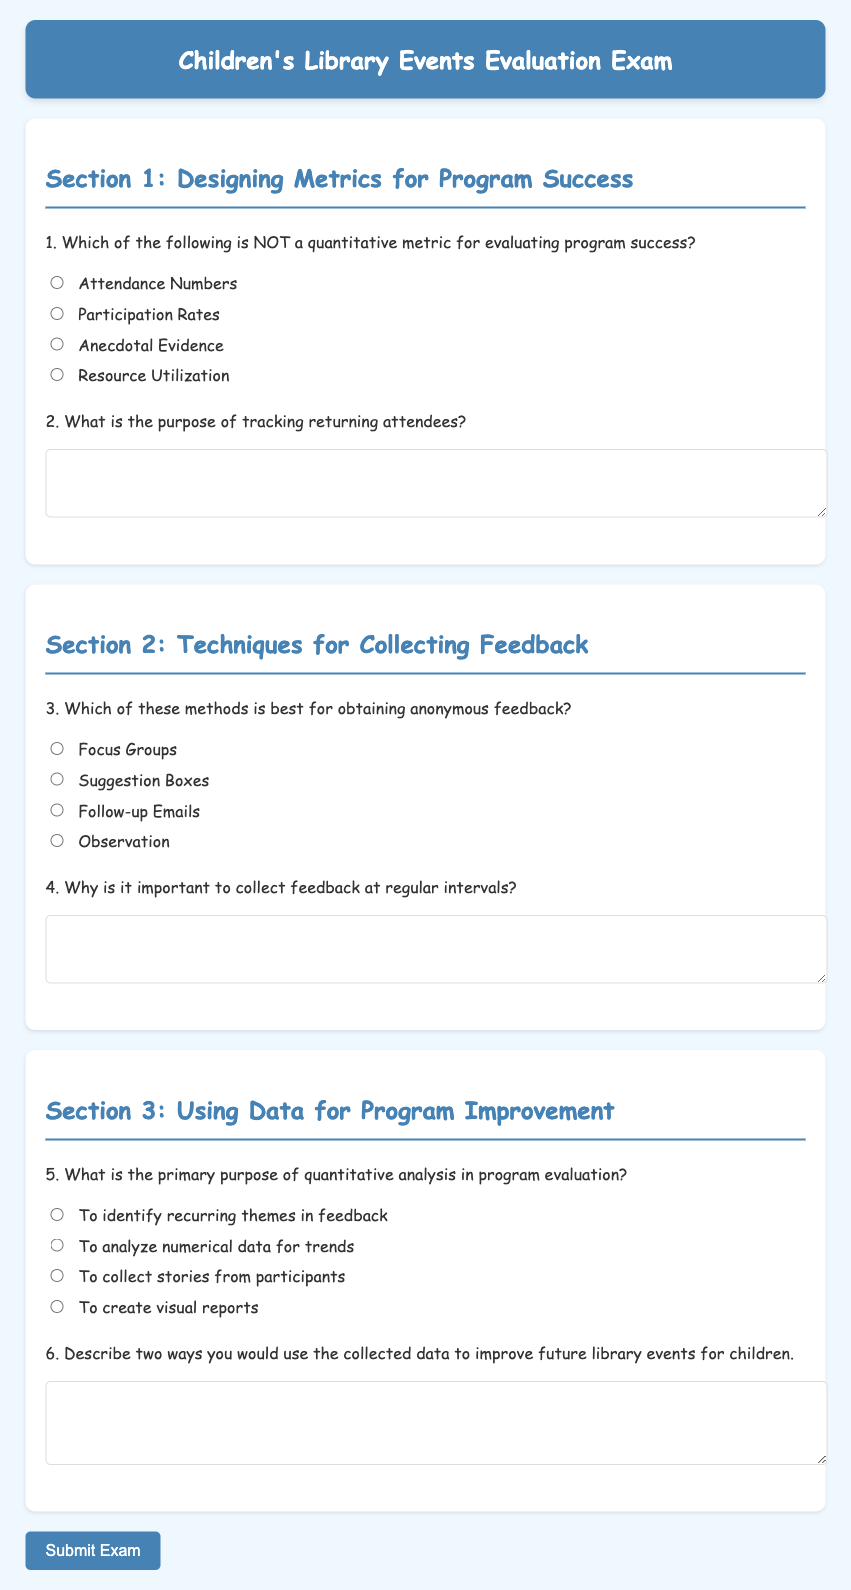What is the title of the exam? The title of the exam is "Children's Library Events Evaluation Exam."
Answer: Children's Library Events Evaluation Exam What is the background color of the page? The background color of the page is specified as "#f0f8ff."
Answer: #f0f8ff What type of font is used in the document? The font used is 'Comic Sans MS,' which is a cursive font.
Answer: Comic Sans MS What section focuses on feedback collection techniques? The section that focuses on feedback collection techniques is labeled "Section 2."
Answer: Section 2 How many questions are there in Section 3? Section 3 contains two questions as indicated in the document.
Answer: 2 What is the purpose of tracking returning attendees? The purpose of tracking returning attendees is to understand engagement and retention.
Answer: Engagement and retention Which method is identified as best for obtaining anonymous feedback? The method identified as best for obtaining anonymous feedback is "Suggestion Boxes."
Answer: Suggestion Boxes What is the primary purpose of quantitative analysis? The primary purpose of quantitative analysis is to analyze numerical data for trends.
Answer: Analyze numerical data for trends How many total sections are in the exam? There are three sections in the exam as indicated in the document structure.
Answer: 3 